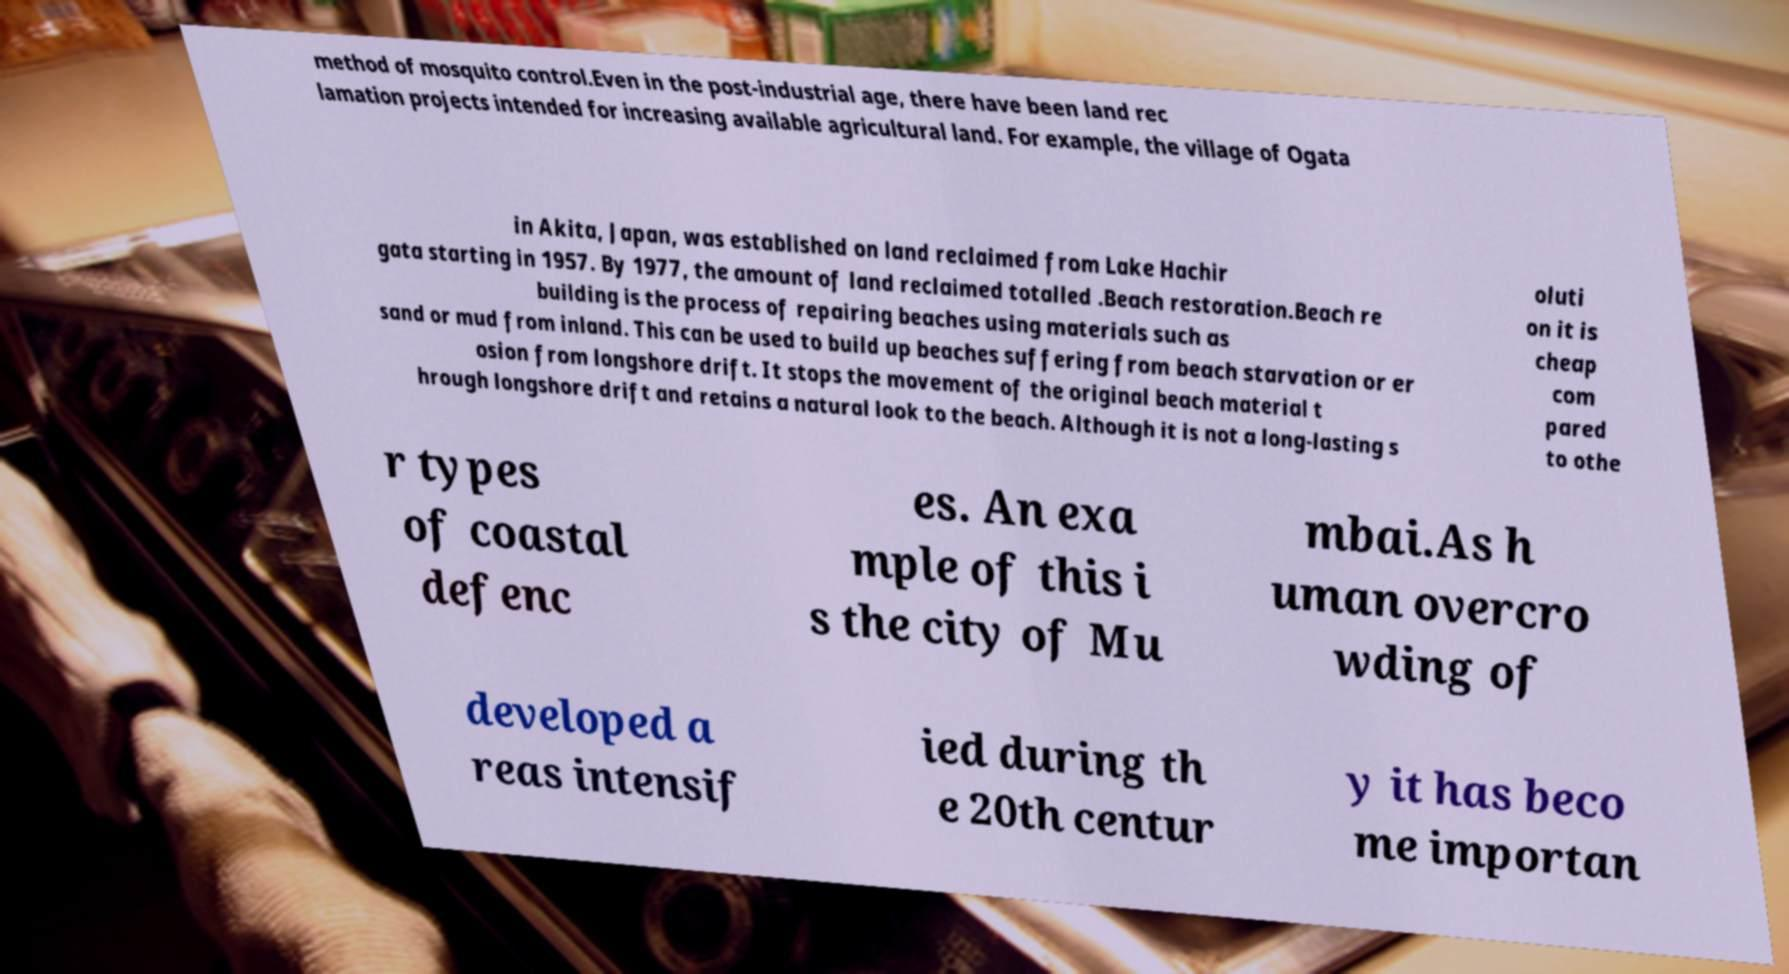Can you read and provide the text displayed in the image?This photo seems to have some interesting text. Can you extract and type it out for me? method of mosquito control.Even in the post-industrial age, there have been land rec lamation projects intended for increasing available agricultural land. For example, the village of Ogata in Akita, Japan, was established on land reclaimed from Lake Hachir gata starting in 1957. By 1977, the amount of land reclaimed totalled .Beach restoration.Beach re building is the process of repairing beaches using materials such as sand or mud from inland. This can be used to build up beaches suffering from beach starvation or er osion from longshore drift. It stops the movement of the original beach material t hrough longshore drift and retains a natural look to the beach. Although it is not a long-lasting s oluti on it is cheap com pared to othe r types of coastal defenc es. An exa mple of this i s the city of Mu mbai.As h uman overcro wding of developed a reas intensif ied during th e 20th centur y it has beco me importan 